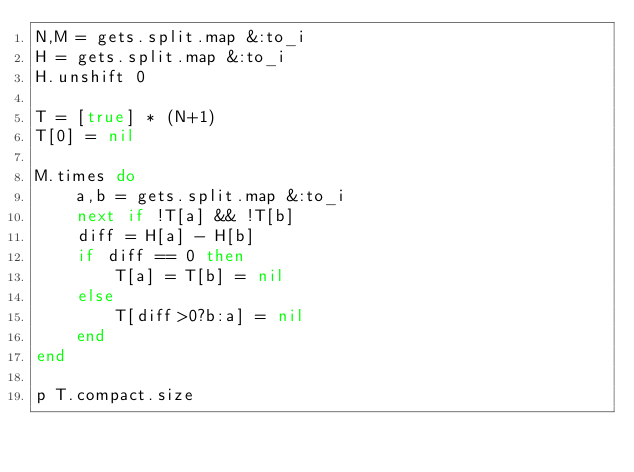Convert code to text. <code><loc_0><loc_0><loc_500><loc_500><_Ruby_>N,M = gets.split.map &:to_i
H = gets.split.map &:to_i
H.unshift 0

T = [true] * (N+1)
T[0] = nil

M.times do 
    a,b = gets.split.map &:to_i
    next if !T[a] && !T[b]
    diff = H[a] - H[b]
    if diff == 0 then
        T[a] = T[b] = nil
    else
        T[diff>0?b:a] = nil
    end
end

p T.compact.size
</code> 